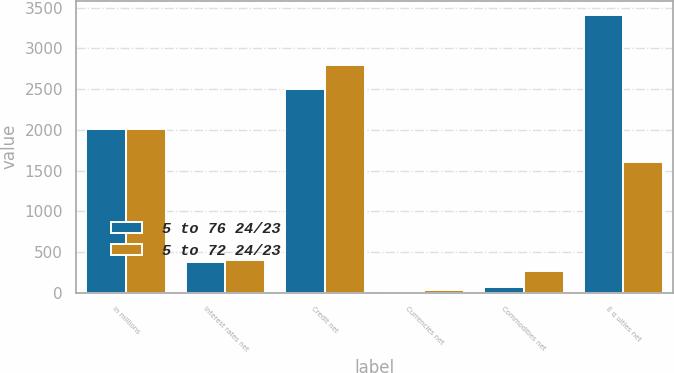Convert chart to OTSL. <chart><loc_0><loc_0><loc_500><loc_500><stacked_bar_chart><ecel><fcel>in millions<fcel>Interest rates net<fcel>Credit net<fcel>Currencies net<fcel>Commodities net<fcel>E q uities net<nl><fcel>5 to 76 24/23<fcel>2016<fcel>381<fcel>2504<fcel>3<fcel>73<fcel>3416<nl><fcel>5 to 72 24/23<fcel>2015<fcel>398<fcel>2793<fcel>34<fcel>262<fcel>1604<nl></chart> 